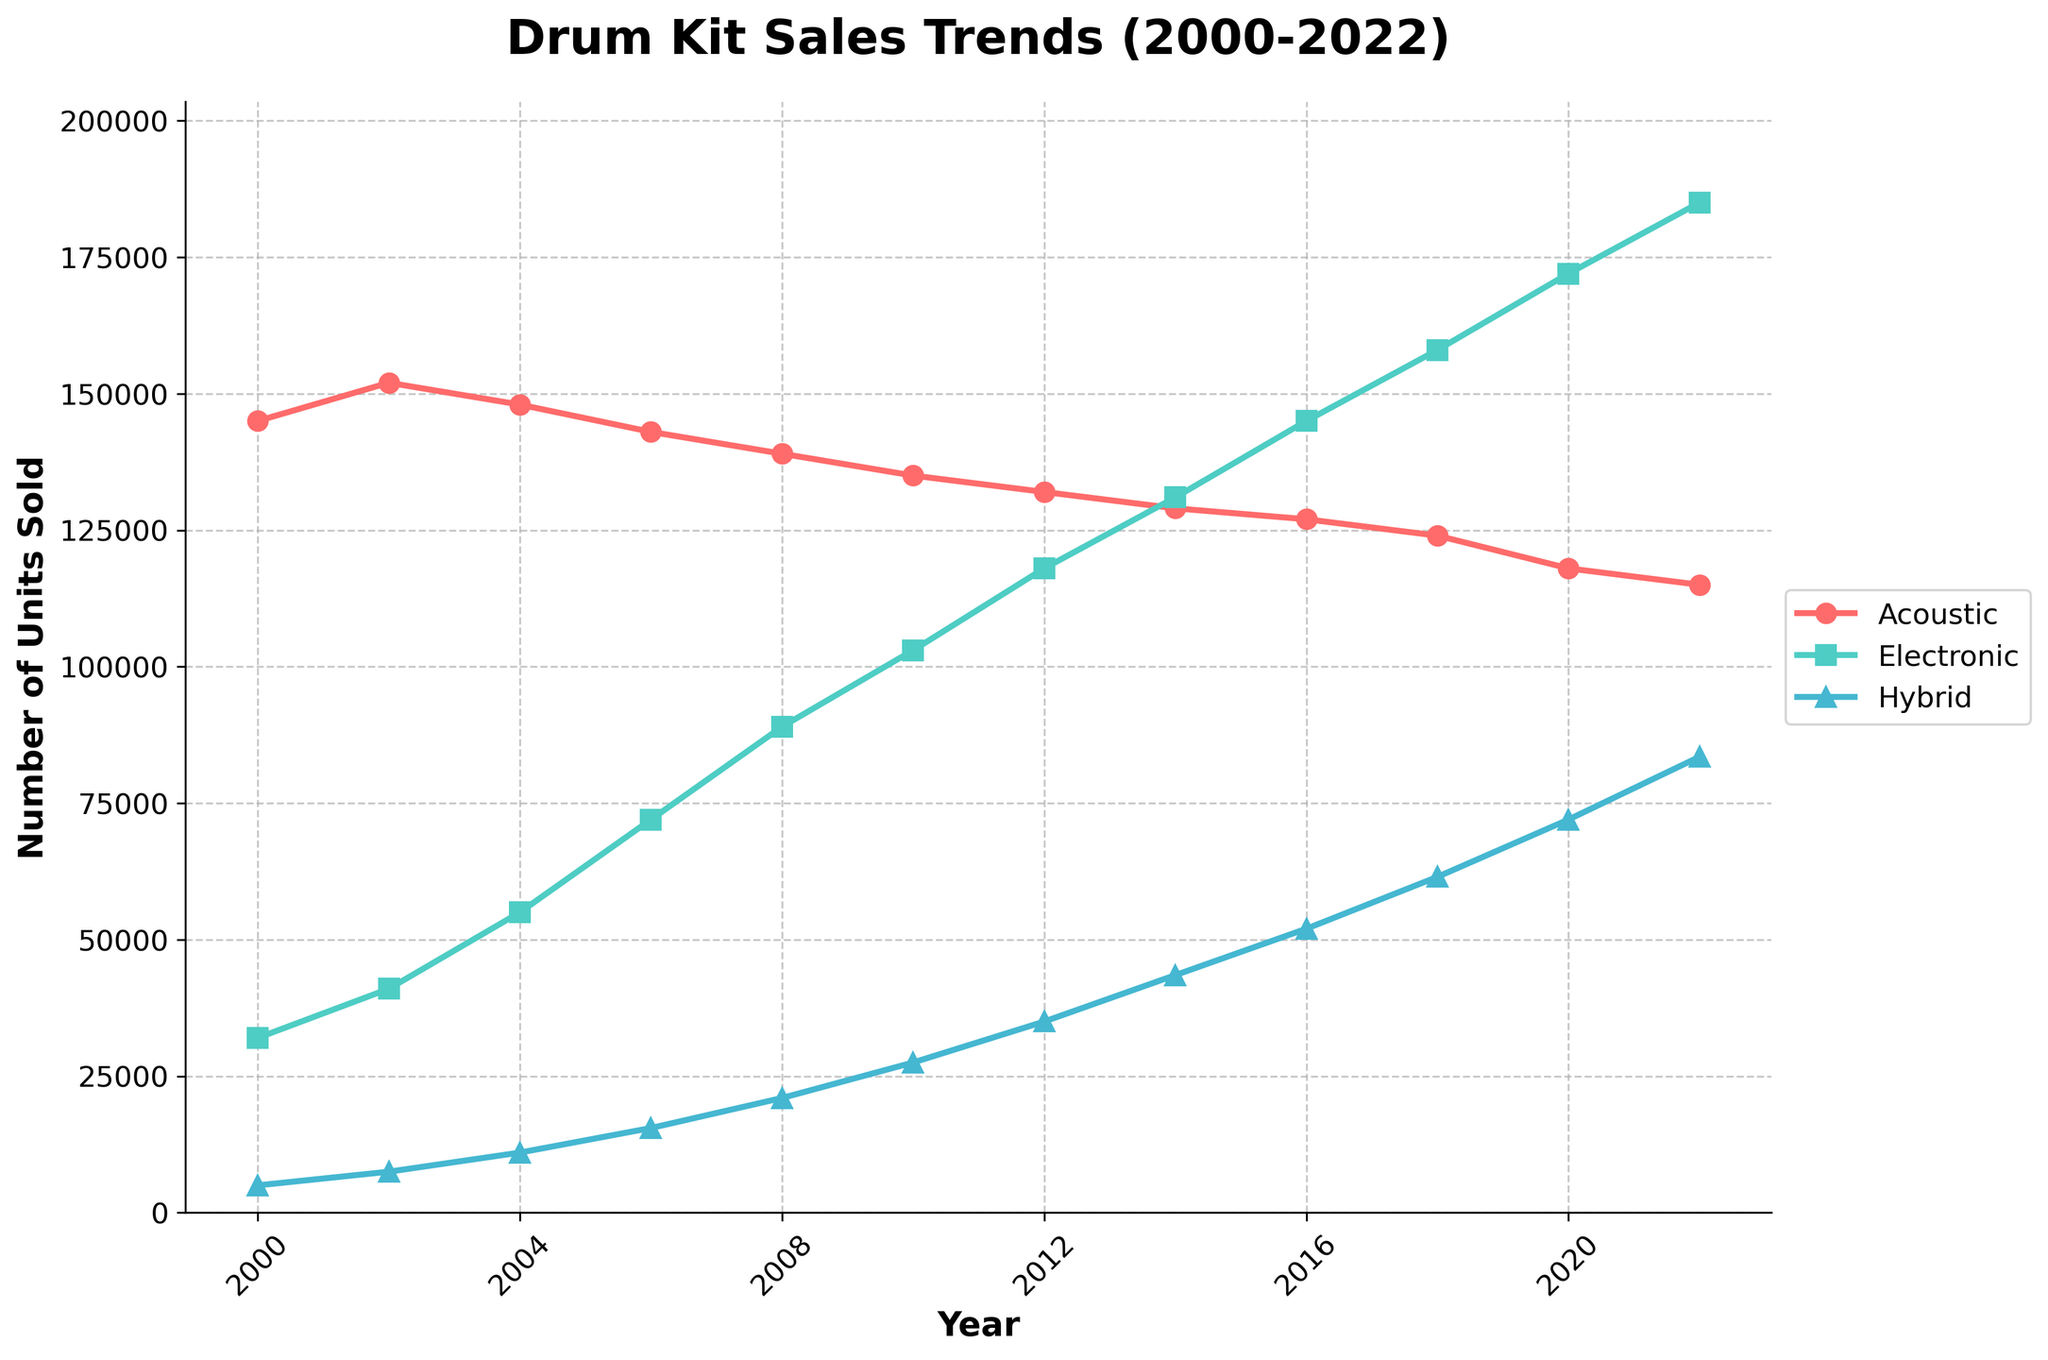What's the trend in sales for Acoustic Drum Kits from 2000 to 2022? Look at the line representing Acoustic Drum Kits. It starts at 145,000 in 2000 and gradually decreases to 115,000 in 2022. This shows a gradual decline over the years.
Answer: The trend is a gradual decline In which year did Electronic Drum Kits sales surpass Acoustic Drum Kits sales? Compare the lines for Acoustic and Electronic Drum Kits. In the year 2016, the number of Electronic Drum Kits sold (145,000) surpassed the number of Acoustic Drum Kits sold (127,000).
Answer: 2016 Which drum kit type had the highest sales in 2020? Look at the values for all three lines in the year 2020. The Electronic Drum Kits line is the highest at 172,000 units, comparing to Acoustic and Hybrid Drum Kits.
Answer: Electronic Drum Kits What is the difference in sales between Acoustic and Electronic Drum Kits in 2010? Look at the points for Acoustic and Electronic Drum Kits in 2010. Subtract the Acoustic sales (135,000) from the Electronic sales (103,000).
Answer: 32,000 more Acoustic Drum Kits How have Hybrid Drum Kits sales changed from 2000 to 2022? Observe the Hybrid Drum Kits line. It starts at 5,000 in 2000 and rises steadily to 83,500 in 2022. This indicates a significant increase.
Answer: Steadily increased In what year did Hybrid Drum Kits cross the 50,000 units sold mark? Follow the Hybrid Drum Kits line and find the point where it crosses 50,000 units. This happens in the year 2016.
Answer: 2016 What is the average annual sales of Acoustic Drum Kits from 2000 to 2022? Add the sales numbers of Acoustic Drum Kits for all the years and divide by the number of years (12). The sum is 145,000 + 152,000 + 148,000 + 143,000 + 139,000 + 135,000 + 132,000 + 129,000 + 127,000 + 124,000 + 118,000 + 115,000 = 1,607,000. Dividing this by 12 gives approximately 134,000 units per year.
Answer: 134,000 units per year Which year saw the highest increase in sales for Hybrid Drum Kits? Calculate the differences in sales of Hybrid Drum Kits for consecutive years and find the maximum value. The most significant increase is from 2016 to 2018, going from 52,000 to 61,500, an increase of 9,500 units.
Answer: 2016-2018 Which drum kit type shows the most consistent trend over the years, and what is that trend? Compare the three lines visually. The Acoustic Drum Kits line shows the most consistent trend, gradually declining with fewer fluctuations compared to the other lines.
Answer: Acoustic Drum Kits, gradual decline 